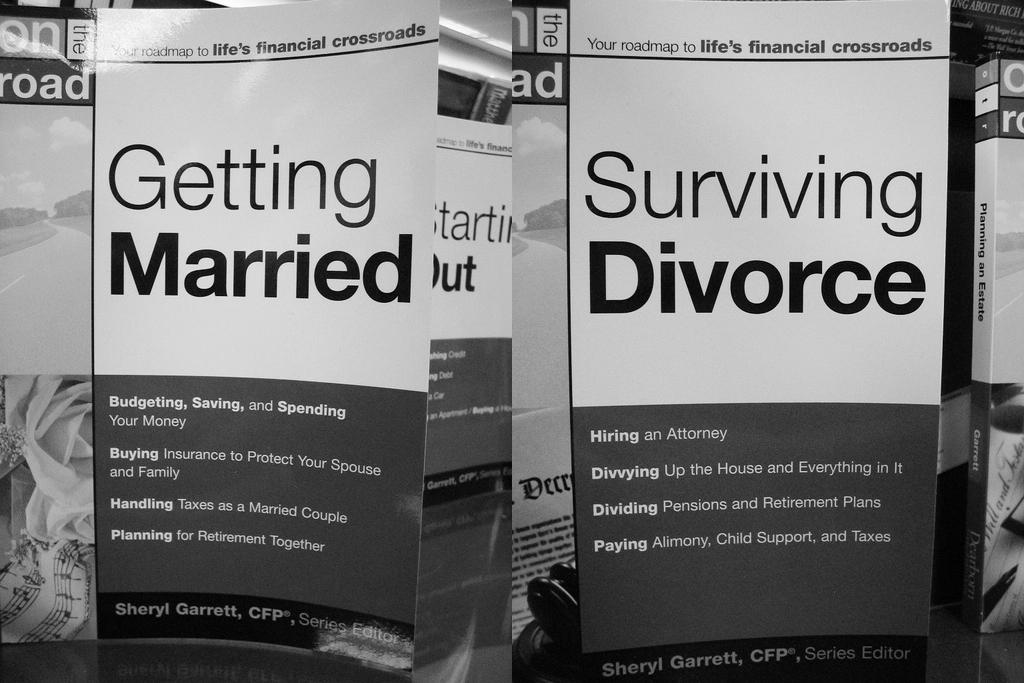Provide a one-sentence caption for the provided image. Several books are shown with the two titles, Getting Married and Surviving Divorce, at the forefront. 